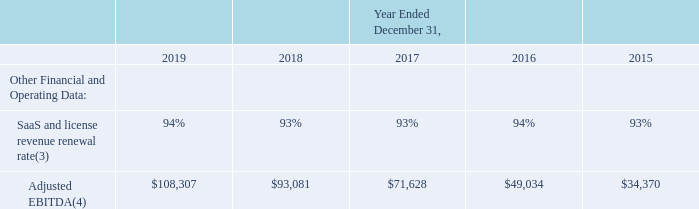ITEM 6. SELECTED FINANCIAL DATA
The selected consolidated statements of operations data for the years ended December 31, 2019, 2018 and 2017 and the selected consolidated balance sheet data as of December 31, 2019 and 2018 are derived from our audited consolidated financial statements included elsewhere in this Annual Report. The selected consolidated statements of operations data for the years ended December 31, 2016 and 2015 and the selected consolidated balance sheet data as of December 31, 2017, 2016 and 2015 are derived from our audited consolidated financial statements not included in this Annual Report. Our historical results are not necessarily indicative of the results to be expected in the future. The selected financial data should be read together with Item 7. "Management’s Discussion and Analysis of Financial Condition and Results of Operations" and in conjunction with our consolidated financial statements, related notes, and other financial information included elsewhere in this Annual Report. The following tables set forth our selected consolidated financial and other data for the years ended and as of December 31, 2019, 2018, 2017, 2016 and 2015 (in thousands, except share and per share data).
Information about prior period acquisitions that may affect the comparability of the selected financial information presented below is included in Item 1. Business. Information about the $28.0 million expense recorded in general and administrative expense in 2018, which relates to the agreement reached to settle the legal matter alleging violations of the Telephone Consumer Protection Act, or TCPA, and may affect the comparability of the selected financial information presented below, is disclosed in Item 3. “Legal Proceedings.” Information about the $1.7 million of interest recorded within interest income and the $6.9 million of gain recorded within other income, net, in 2019, which relates to promissory note proceeds received from one of our hardware suppliers and proceeds from an acquired promissory note, and may affect the comparability of the selected financial information presented below, is disclosed in Item 7. "Management’s Discussion and Analysis of Financial Condition and Results of Operations."
Certain previously reported amounts in the consolidated statements of operations for the years ended December 31, 2018, 2017, 2016 and 2015 have been reclassified to conform to our current presentation to reflect interest income as a separate line item, which was previously included in other income, net.
(3) We measure our SaaS and license revenue renewal rate on a trailing 12-month basis by dividing (a) the total SaaS and license revenue recognized during the trailing 12-month period from subscribers on our Alarm.com platform who were subscribers on the first day of the period, by (b) total SaaS and license revenue we would have recognized during the period from those same subscribers assuming no terminations, or service level upgrades or downgrades. The SaaS and license revenue renewal rate represents both residential and commercial properties. Our SaaS and license revenue renewal rate is expressed as an annualized percentage. Our service provider partners, who resell our services to our subscribers, have indicated that they typically have three to five-year service contracts with our subscribers. Our SaaS and license revenue renewal rate is calculated across our entire subscriber base on the Alarm.com platform, including subscribers whose contract with their service provider reached the end of its contractual term during the measurement period, as well as subscribers whose contract with their service provider has not reached the end of its contractual term during the measurement period, and is not intended to estimate the rate at which our subscribers renew their contracts with our service provider partners. We believe that our SaaS and license revenue renewal rate allows us to measure our ability to retain and grow our SaaS and license revenue and serves as an indicator of the lifetime value of our subscriber base.
(4) We define Adjusted EBITDA as our net income before interest expense, interest income, other income, net, provision for / (benefit from) income taxes, amortization and depreciation expense, stock-based compensation expense, acquisition-related expense and legal costs and settlement fees incurred in connection with non-ordinary course litigation and other disputes, particularly costs involved in ongoing intellectual property litigation. We do not consider these items to be indicative of our core operating performance. The non-cash items include amortization and depreciation expense and stock-based compensation expense. Included in 2015 stock-based compensation expense is $0.8 million related to the repurchase of an employee's stock awards. We do not adjust for ordinary course legal expenses resulting from maintaining and enforcing our intellectual property portfolio and license agreements. Adjusted EBITDA is not a measure calculated in accordance with accounting principles generally accepted in the United States, or GAAP. See the table below for a reconciliation of Adjusted EBITDA to net income, the most directly comparable financial measure calculated and presented in accordance with GAAP.
What was the adjusted EBITDA in 2019?
Answer scale should be: thousand. $108,307. What was the SaaS and license revenue renewal rate in 2018? 93%. Which years does the table provide data for adjusted EBITDA for? 2019, 2018, 2017, 2016, 2015. How many years did the adjusted EBITDA exceed $50,000 thousand? 2019##2018##2017
Answer: 3. What was the change in the SaaS and license revenue renewal rate between 2018 and 2019?
Answer scale should be: percent. 94-93
Answer: 1. What was the percentage change in adjusted EBITDA between 2018 and 2019?
Answer scale should be: percent. (108,307-93,081)/93,081
Answer: 16.36. 